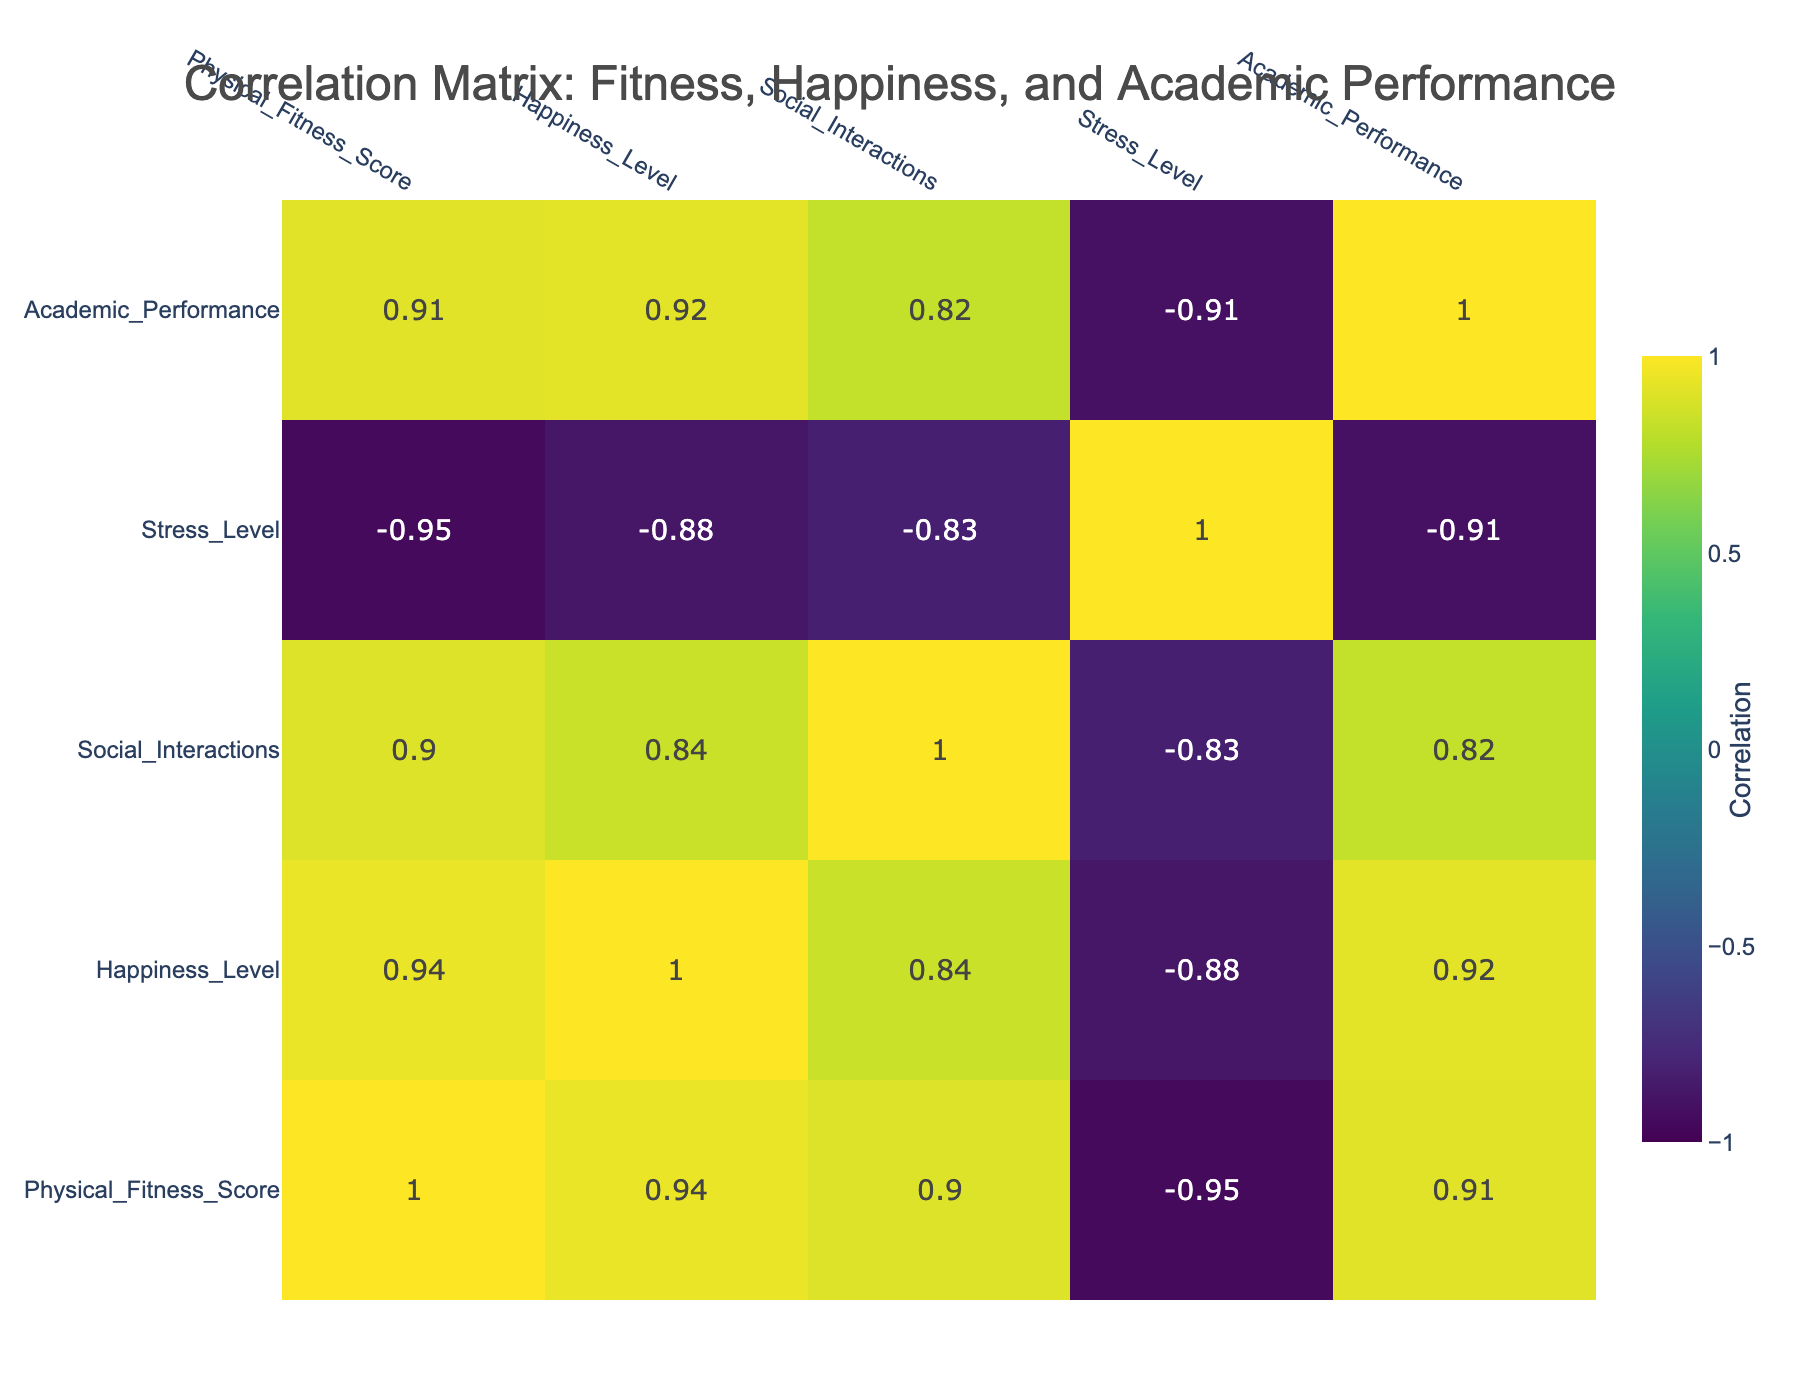What is the correlation between Physical Fitness Score and Happiness Level? By inspecting the correlation matrix, we check the value where the Physical Fitness Score row meets the Happiness Level column. The table shows a correlation of 0.85, indicating a strong positive relationship between the two variables.
Answer: 0.85 Which student has the highest Happiness Level? Looking at the Happiness Level column, we find that Laura Wilson has the highest score of 10.
Answer: Laura Wilson Is there a correlation between Stress Level and Happiness Level? Referring to the correlation matrix, we identify the cell at the intersection of Stress Level and Happiness Level, which reads -0.67. This negative correlation implies that as stress levels increase, happiness levels decrease.
Answer: Yes What is the average Physical Fitness Score of students with a Happiness Level of 6? First, locate all the students with a Happiness Level of 6, which includes Sarah Williams, Karen Jones, Jessica Martinez, Daniel Rodriguez, and Nicole Thomas. Their Physical Fitness Scores are 65, 70, 60, 75, and 73. Summing those gives 65 + 70 + 60 + 75 + 73 = 343. Dividing this by the number of students (5) results in an average score of 343 / 5 = 68.6.
Answer: 68.6 Does higher Physical Fitness correlate with better Academic Performance? To determine this, we examine the correlation between Physical Fitness Score and Academic Performance in the matrix. The correlation is 0.42, indicating a moderate positive correlation, meaning that higher physical fitness tends to relate to better academic performance.
Answer: Yes 